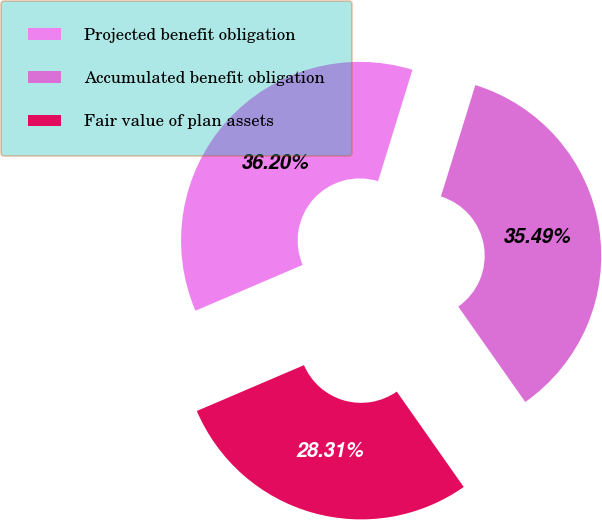<chart> <loc_0><loc_0><loc_500><loc_500><pie_chart><fcel>Projected benefit obligation<fcel>Accumulated benefit obligation<fcel>Fair value of plan assets<nl><fcel>36.2%<fcel>35.49%<fcel>28.31%<nl></chart> 